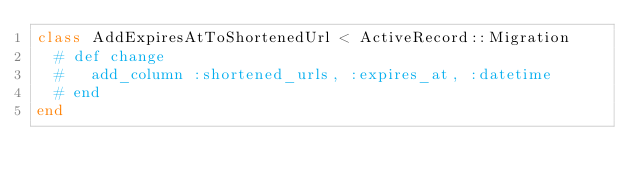Convert code to text. <code><loc_0><loc_0><loc_500><loc_500><_Ruby_>class AddExpiresAtToShortenedUrl < ActiveRecord::Migration
  # def change
  #   add_column :shortened_urls, :expires_at, :datetime
  # end
end
</code> 